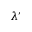<formula> <loc_0><loc_0><loc_500><loc_500>\lambda ^ { \prime }</formula> 